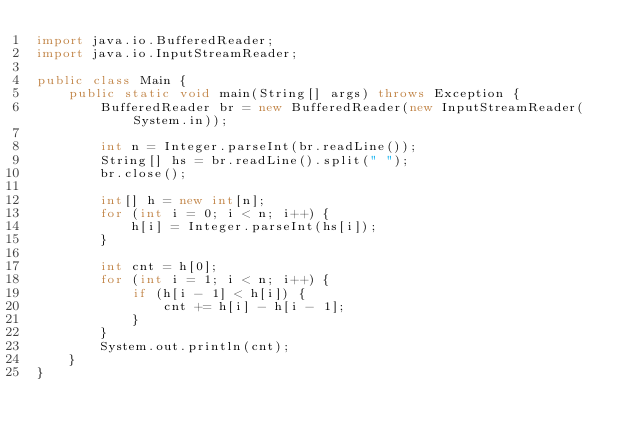Convert code to text. <code><loc_0><loc_0><loc_500><loc_500><_Java_>import java.io.BufferedReader;
import java.io.InputStreamReader;

public class Main {
	public static void main(String[] args) throws Exception {
		BufferedReader br = new BufferedReader(new InputStreamReader(System.in));

		int n = Integer.parseInt(br.readLine());
		String[] hs = br.readLine().split(" ");
		br.close();

		int[] h = new int[n];
		for (int i = 0; i < n; i++) {
			h[i] = Integer.parseInt(hs[i]);
		}

		int cnt = h[0];
		for (int i = 1; i < n; i++) {
			if (h[i - 1] < h[i]) {
				cnt += h[i] - h[i - 1];
			}
		}
		System.out.println(cnt);
	}
}
</code> 